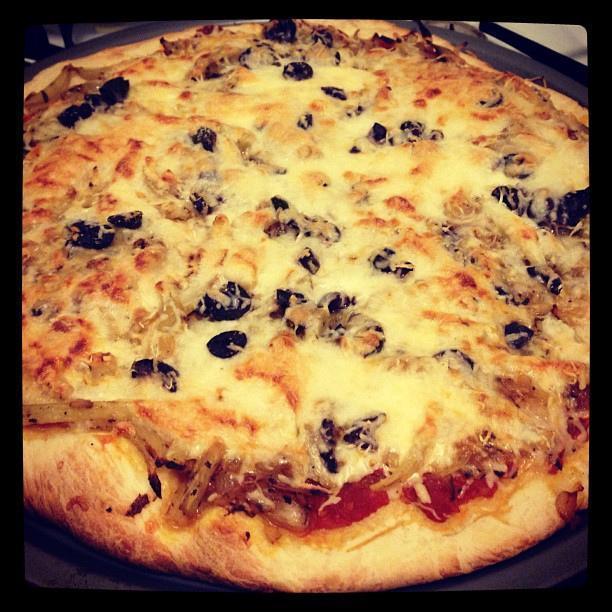How many pizzas can be seen?
Give a very brief answer. 1. How many people are on a motorcycle in the image?
Give a very brief answer. 0. 